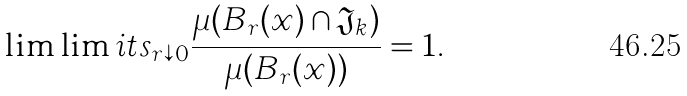Convert formula to latex. <formula><loc_0><loc_0><loc_500><loc_500>\lim \lim i t s _ { r \downarrow 0 } \frac { \mu ( B _ { r } ( x ) \cap \mathfrak { J } _ { k } ) } { \mu ( B _ { r } ( x ) ) } = 1 .</formula> 